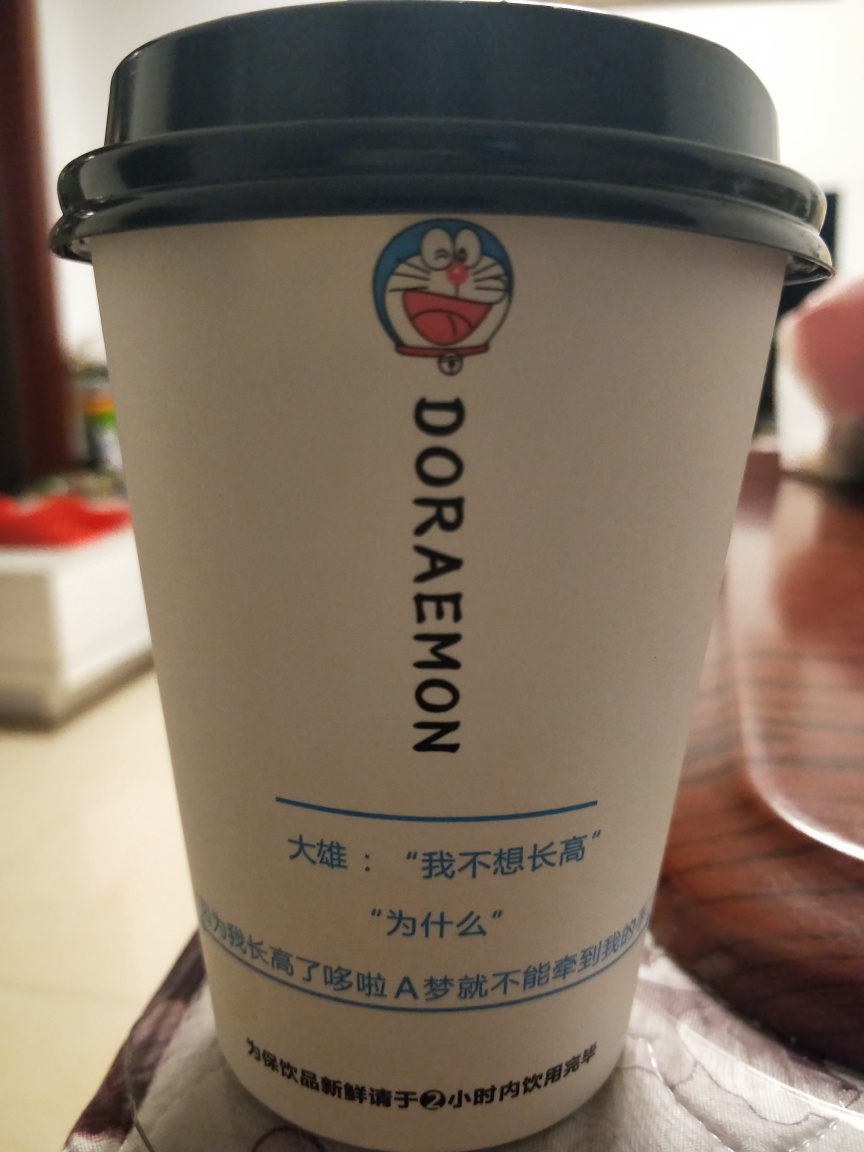Imagine I wanted to purchase this cup; where do you think I could find it? While I can't provide shopping options, this type of branded merchandise is often available at stores that sell anime-related products, gift shops, or online marketplaces. It might also be found at special events or conventions dedicated to anime and manga-related items. Checking with retailers that specialize in Japanese pop culture could be a good starting point. 